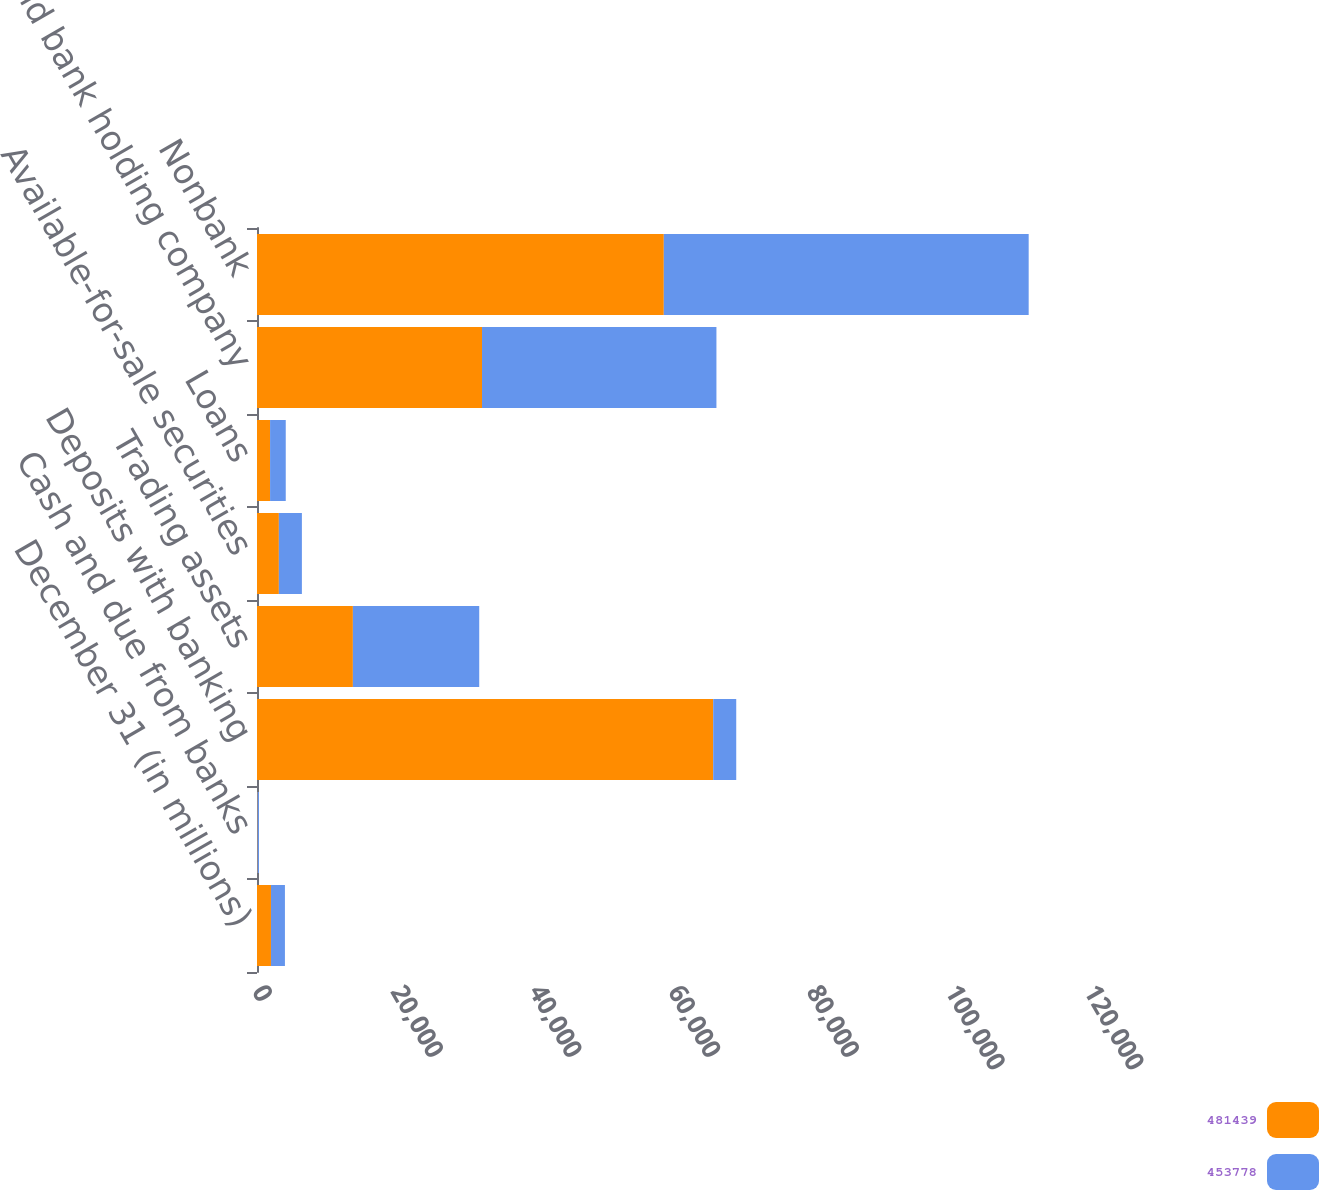Convert chart to OTSL. <chart><loc_0><loc_0><loc_500><loc_500><stacked_bar_chart><ecel><fcel>December 31 (in millions)<fcel>Cash and due from banks<fcel>Deposits with banking<fcel>Trading assets<fcel>Available-for-sale securities<fcel>Loans<fcel>Bank and bank holding company<fcel>Nonbank<nl><fcel>481439<fcel>2015<fcel>74<fcel>65799<fcel>13830<fcel>3154<fcel>1887<fcel>32454<fcel>58674<nl><fcel>453778<fcel>2014<fcel>211<fcel>3321<fcel>18222<fcel>3321<fcel>2260<fcel>33810<fcel>52626<nl></chart> 